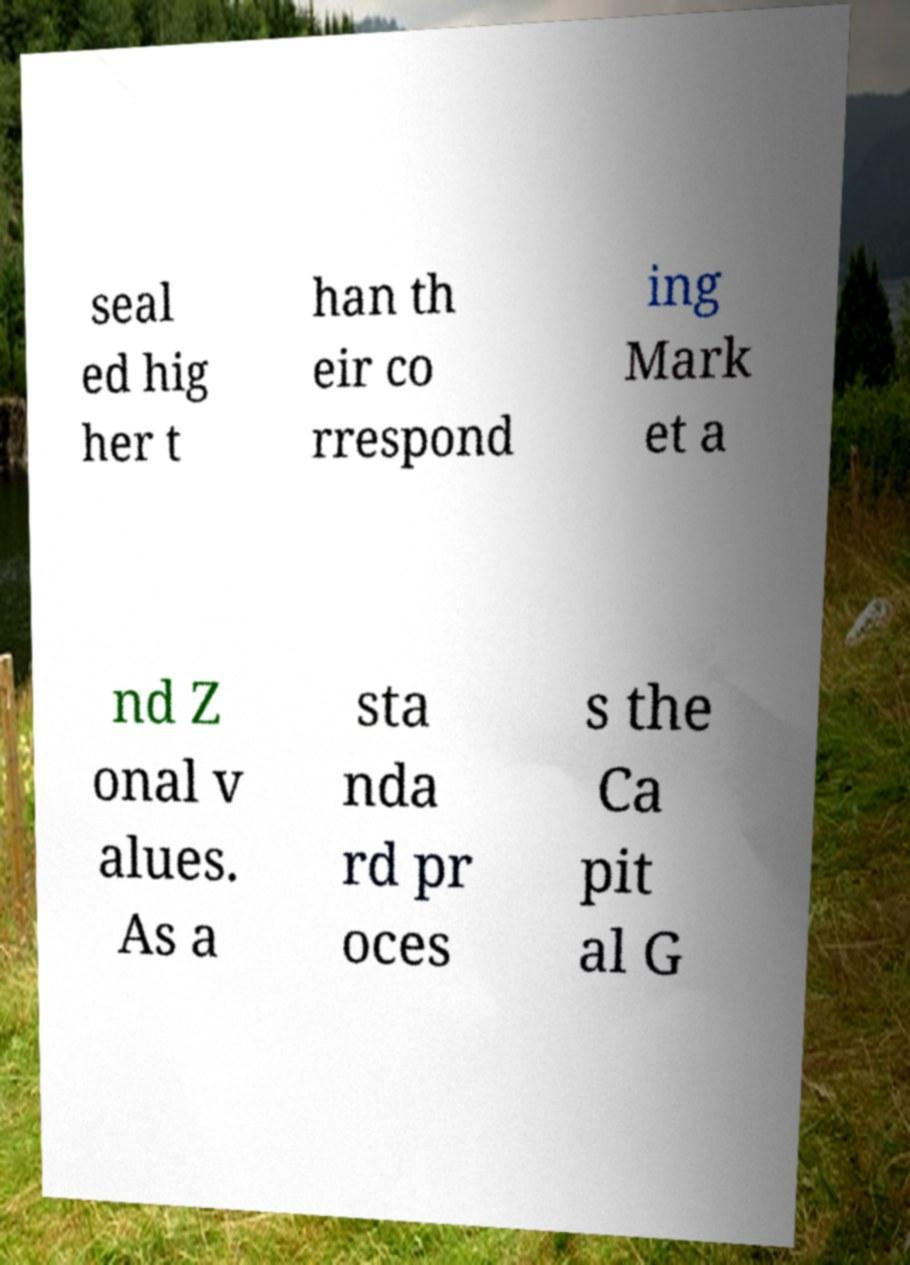What messages or text are displayed in this image? I need them in a readable, typed format. seal ed hig her t han th eir co rrespond ing Mark et a nd Z onal v alues. As a sta nda rd pr oces s the Ca pit al G 